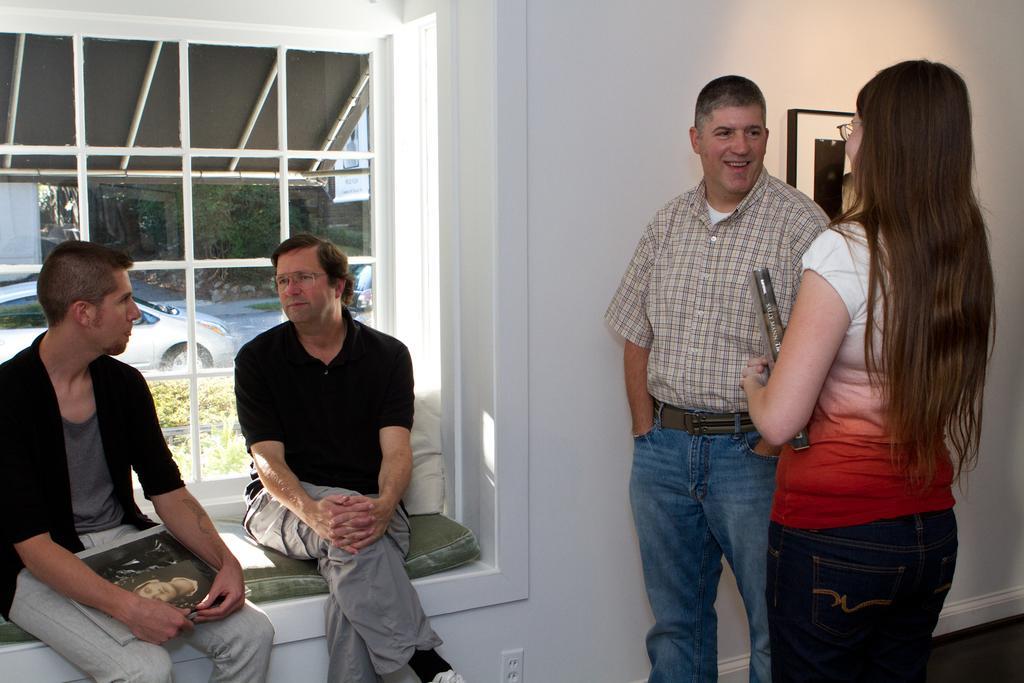Describe this image in one or two sentences. In a room there are four people, three men and a woman. Two people are sitting in front of a window and beside them there is a wall and in front of the wall the woman and the man standing and talking to each other, there is a photo frame attached to the wall, outside the window there are some vehicles parked beside the plants. 